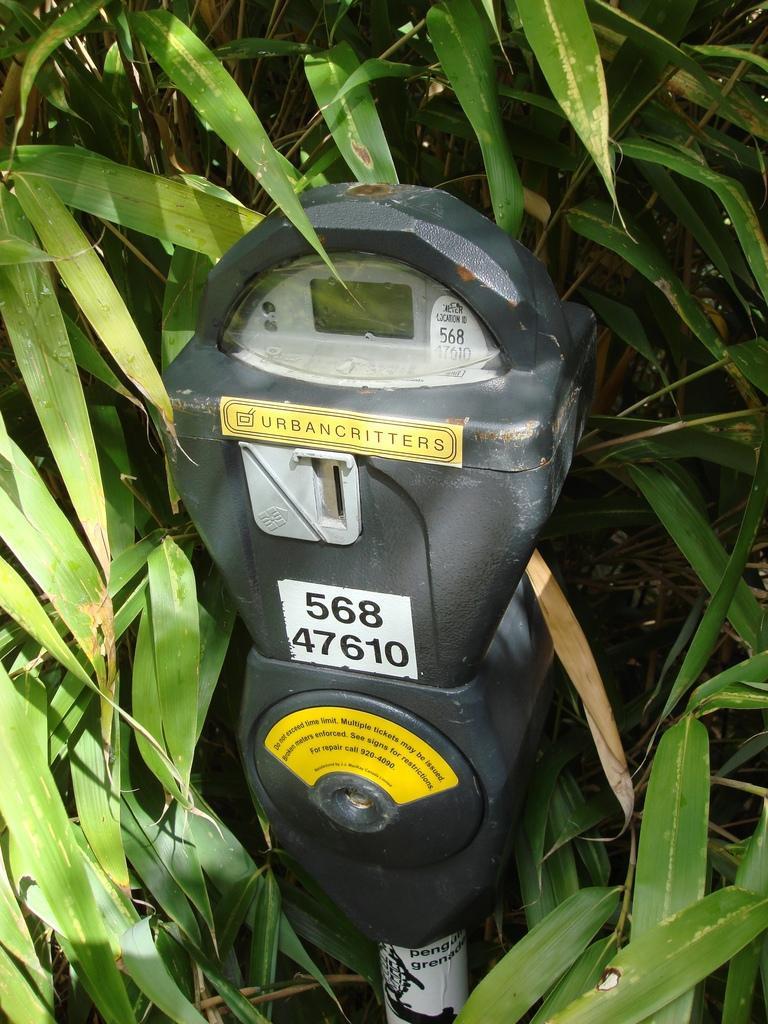<image>
Create a compact narrative representing the image presented. A parking meter reads 56847610 on the front. 